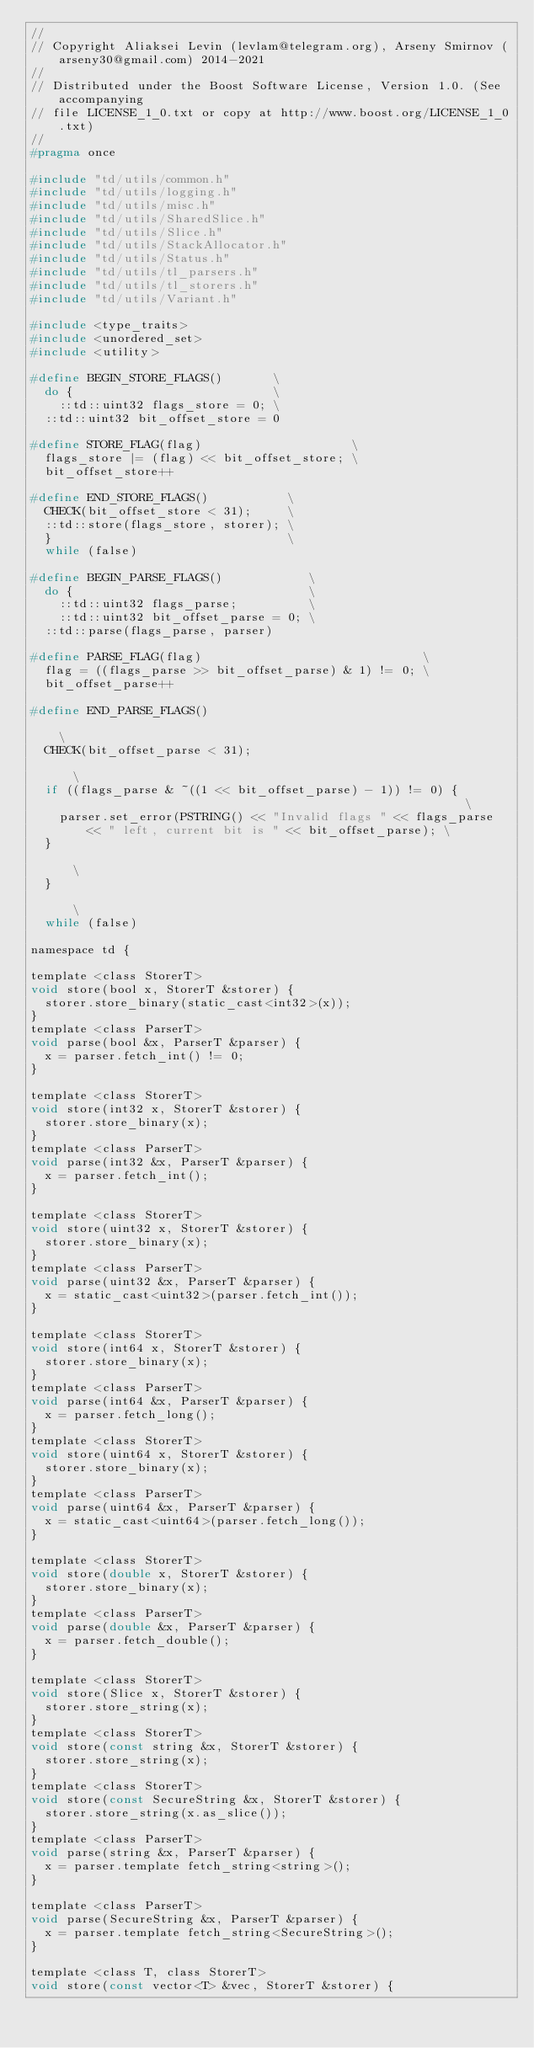Convert code to text. <code><loc_0><loc_0><loc_500><loc_500><_C_>//
// Copyright Aliaksei Levin (levlam@telegram.org), Arseny Smirnov (arseny30@gmail.com) 2014-2021
//
// Distributed under the Boost Software License, Version 1.0. (See accompanying
// file LICENSE_1_0.txt or copy at http://www.boost.org/LICENSE_1_0.txt)
//
#pragma once

#include "td/utils/common.h"
#include "td/utils/logging.h"
#include "td/utils/misc.h"
#include "td/utils/SharedSlice.h"
#include "td/utils/Slice.h"
#include "td/utils/StackAllocator.h"
#include "td/utils/Status.h"
#include "td/utils/tl_parsers.h"
#include "td/utils/tl_storers.h"
#include "td/utils/Variant.h"

#include <type_traits>
#include <unordered_set>
#include <utility>

#define BEGIN_STORE_FLAGS()       \
  do {                            \
    ::td::uint32 flags_store = 0; \
  ::td::uint32 bit_offset_store = 0

#define STORE_FLAG(flag)                     \
  flags_store |= (flag) << bit_offset_store; \
  bit_offset_store++

#define END_STORE_FLAGS()           \
  CHECK(bit_offset_store < 31);     \
  ::td::store(flags_store, storer); \
  }                                 \
  while (false)

#define BEGIN_PARSE_FLAGS()            \
  do {                                 \
    ::td::uint32 flags_parse;          \
    ::td::uint32 bit_offset_parse = 0; \
  ::td::parse(flags_parse, parser)

#define PARSE_FLAG(flag)                               \
  flag = ((flags_parse >> bit_offset_parse) & 1) != 0; \
  bit_offset_parse++

#define END_PARSE_FLAGS()                                                                                           \
  CHECK(bit_offset_parse < 31);                                                                                     \
  if ((flags_parse & ~((1 << bit_offset_parse) - 1)) != 0) {                                                        \
    parser.set_error(PSTRING() << "Invalid flags " << flags_parse << " left, current bit is " << bit_offset_parse); \
  }                                                                                                                 \
  }                                                                                                                 \
  while (false)

namespace td {

template <class StorerT>
void store(bool x, StorerT &storer) {
  storer.store_binary(static_cast<int32>(x));
}
template <class ParserT>
void parse(bool &x, ParserT &parser) {
  x = parser.fetch_int() != 0;
}

template <class StorerT>
void store(int32 x, StorerT &storer) {
  storer.store_binary(x);
}
template <class ParserT>
void parse(int32 &x, ParserT &parser) {
  x = parser.fetch_int();
}

template <class StorerT>
void store(uint32 x, StorerT &storer) {
  storer.store_binary(x);
}
template <class ParserT>
void parse(uint32 &x, ParserT &parser) {
  x = static_cast<uint32>(parser.fetch_int());
}

template <class StorerT>
void store(int64 x, StorerT &storer) {
  storer.store_binary(x);
}
template <class ParserT>
void parse(int64 &x, ParserT &parser) {
  x = parser.fetch_long();
}
template <class StorerT>
void store(uint64 x, StorerT &storer) {
  storer.store_binary(x);
}
template <class ParserT>
void parse(uint64 &x, ParserT &parser) {
  x = static_cast<uint64>(parser.fetch_long());
}

template <class StorerT>
void store(double x, StorerT &storer) {
  storer.store_binary(x);
}
template <class ParserT>
void parse(double &x, ParserT &parser) {
  x = parser.fetch_double();
}

template <class StorerT>
void store(Slice x, StorerT &storer) {
  storer.store_string(x);
}
template <class StorerT>
void store(const string &x, StorerT &storer) {
  storer.store_string(x);
}
template <class StorerT>
void store(const SecureString &x, StorerT &storer) {
  storer.store_string(x.as_slice());
}
template <class ParserT>
void parse(string &x, ParserT &parser) {
  x = parser.template fetch_string<string>();
}

template <class ParserT>
void parse(SecureString &x, ParserT &parser) {
  x = parser.template fetch_string<SecureString>();
}

template <class T, class StorerT>
void store(const vector<T> &vec, StorerT &storer) {</code> 